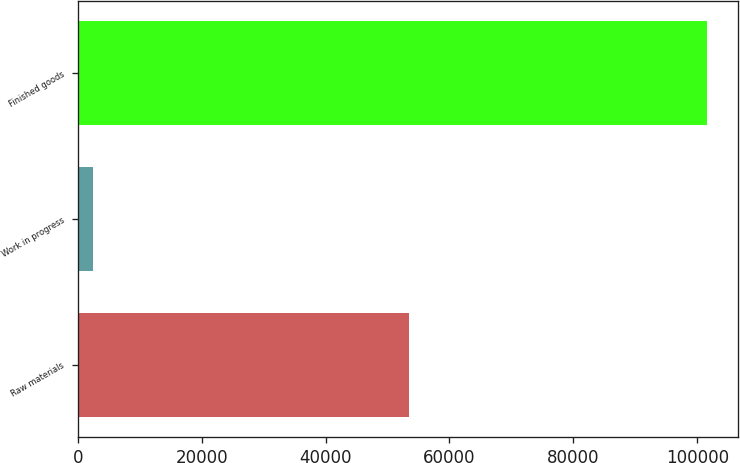<chart> <loc_0><loc_0><loc_500><loc_500><bar_chart><fcel>Raw materials<fcel>Work in progress<fcel>Finished goods<nl><fcel>53392<fcel>2500<fcel>101539<nl></chart> 